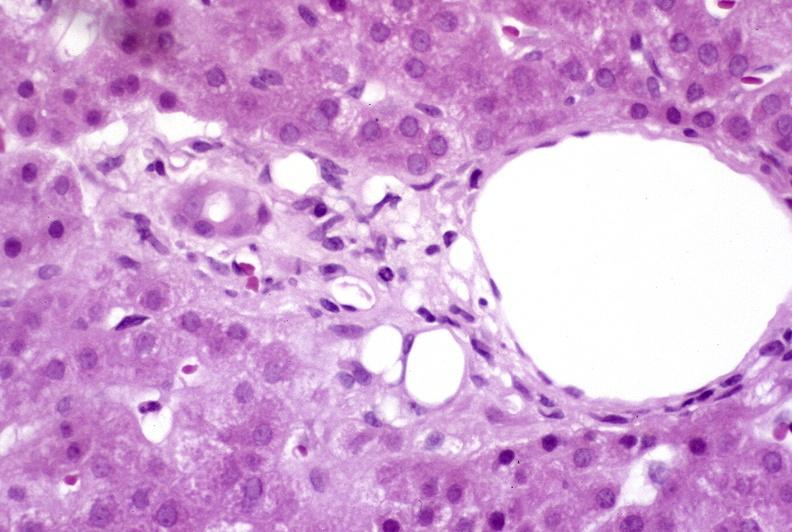what is present?
Answer the question using a single word or phrase. Hepatobiliary 